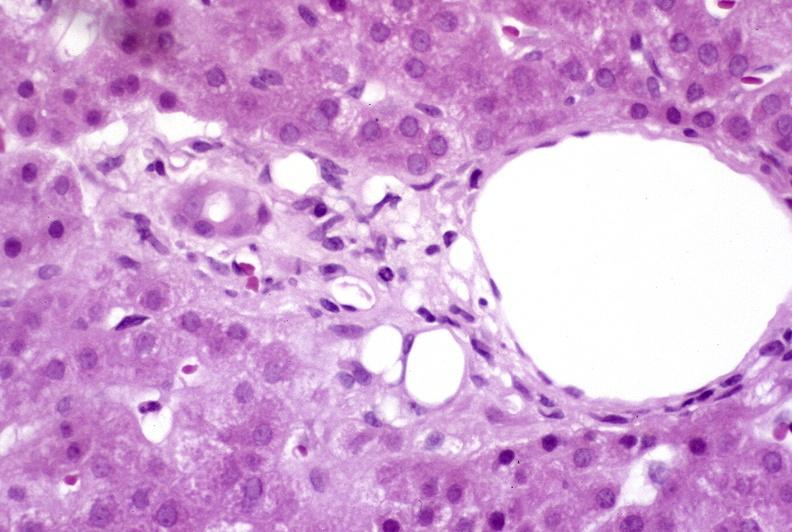what is present?
Answer the question using a single word or phrase. Hepatobiliary 